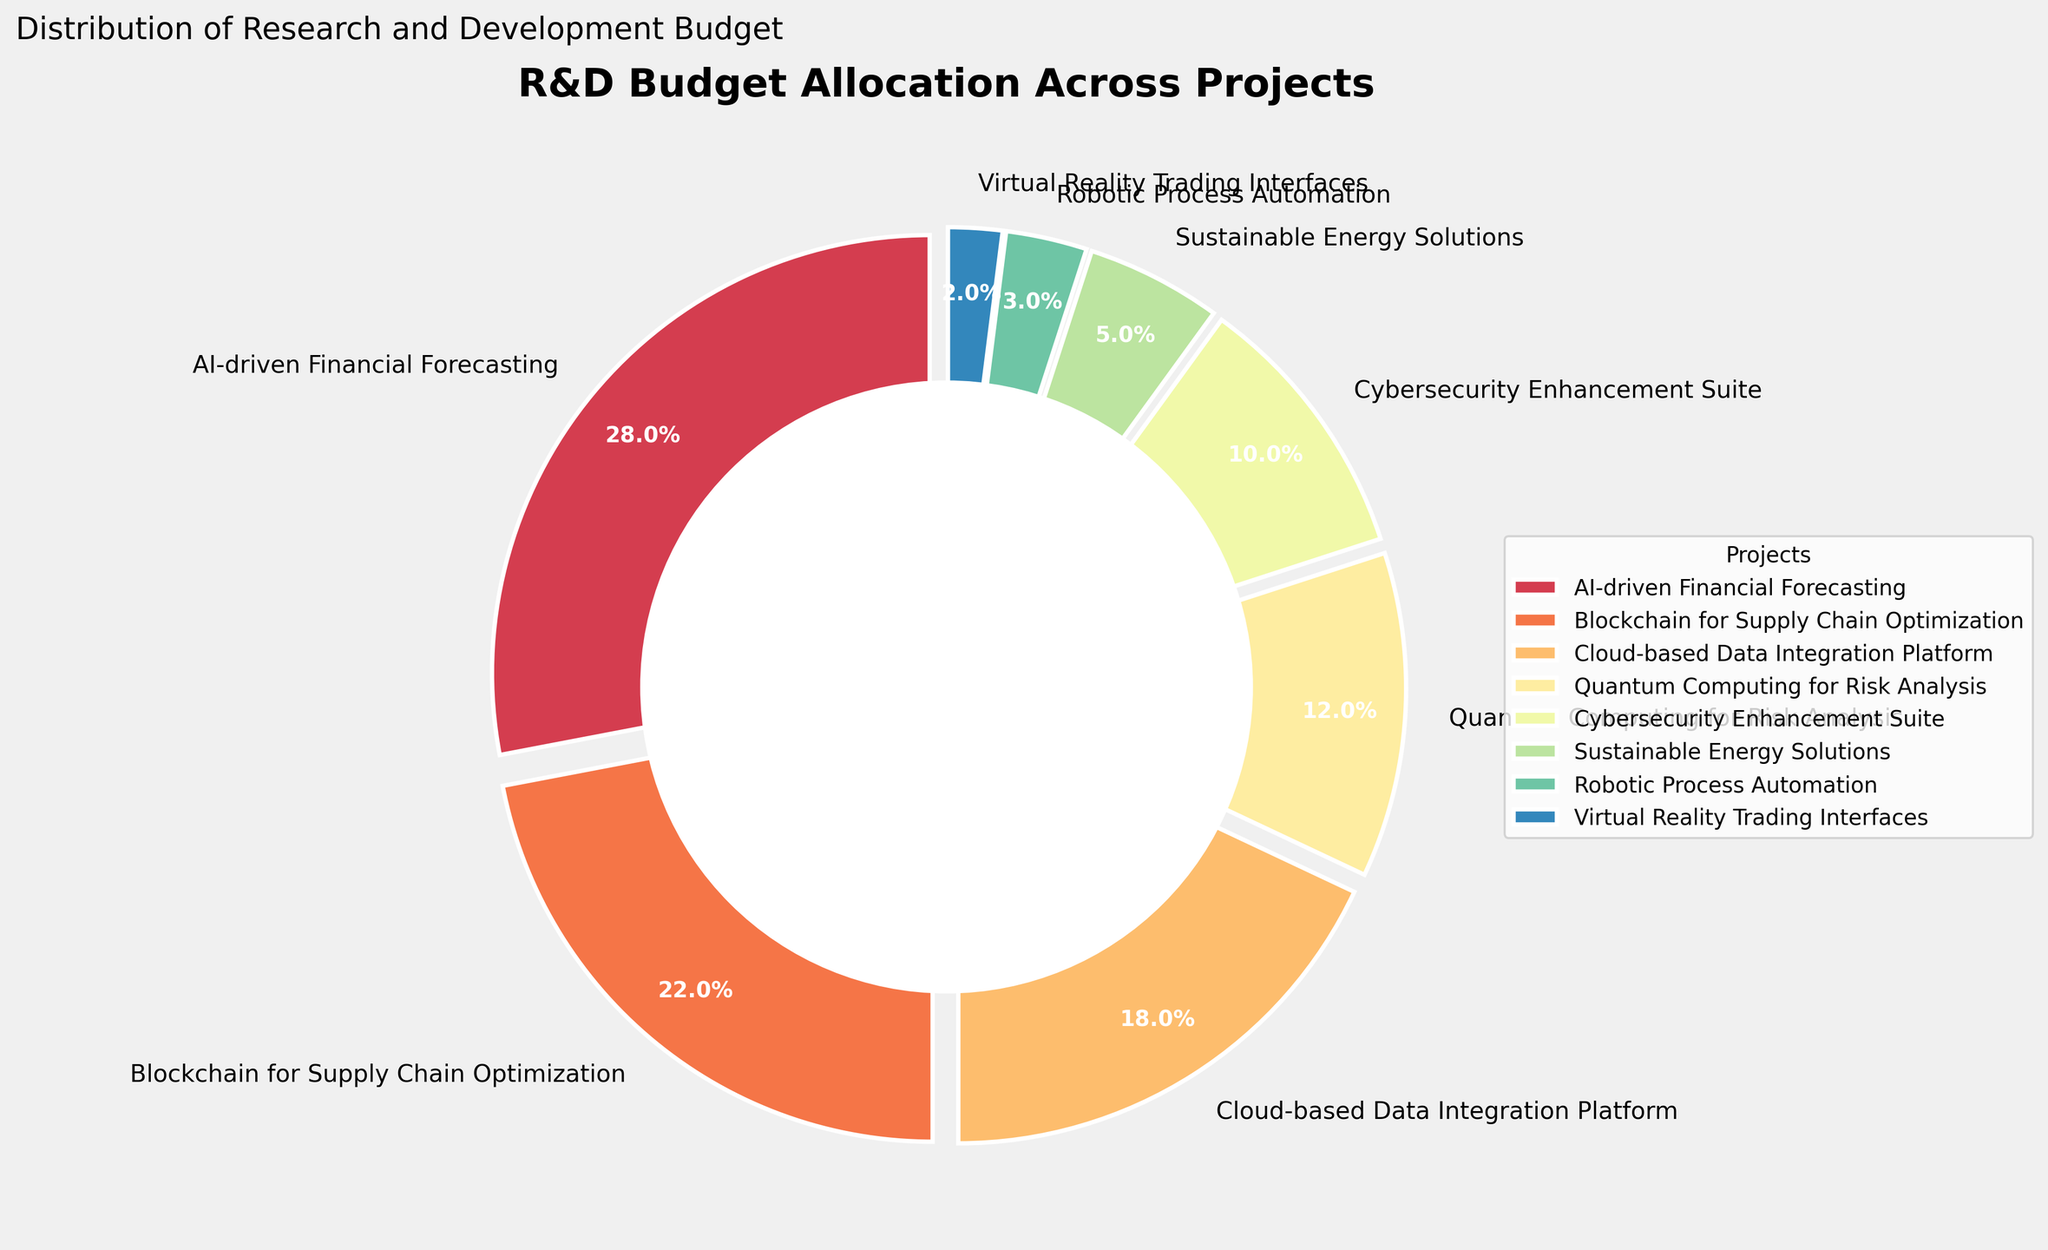What percentage of the budget is allocated to AI-driven Financial Forecasting? The figure shows that AI-driven Financial Forecasting has a budget allocation represented by a specific percentage segment of the pie. Looking directly at the figure, this segment is labeled with its percentage.
Answer: 28% Which project has the second-highest budget allocation? In the pie chart, the second-largest segment after AI-driven Financial Forecasting represents the second-highest budget allocation. This segment is labeled with its project name.
Answer: Blockchain for Supply Chain Optimization How much more budget percentage is allocated to Cloud-based Data Integration Platform compared to Sustainable Energy Solutions? First, find the budget percentages for both projects from the pie chart (18% for Cloud-based Data Integration Platform and 5% for Sustainable Energy Solutions). Then, subtract the smaller percentage from the larger one: 18% - 5% = 13%.
Answer: 13% Compare the budget allocations for Quantum Computing for Risk Analysis and Cybersecurity Enhancement Suite. Which has more, and by how much? Identify the budget percentages for both projects from the pie chart (12% for Quantum Computing for Risk Analysis and 10% for Cybersecurity Enhancement Suite). Subtract the smaller percentage from the larger one: 12% - 10% = 2%. Quantum Computing for Risk Analysis has 2% more.
Answer: Quantum Computing for Risk Analysis, 2% If projects with a budget allocation below 5% were combined into one category, what would be their total budget percentage? Identify the projects with budget allocations below 5% from the pie chart: Robotic Process Automation (3%) and Virtual Reality Trading Interfaces (2%). Sum these percentages: 3% + 2% = 5%.
Answer: 5% What is the overall budget percentage for the three highest-funded projects? Identify the three highest-funded projects from the pie chart, which are AI-driven Financial Forecasting (28%), Blockchain for Supply Chain Optimization (22%), and Cloud-based Data Integration Platform (18%). Sum these percentages: 28% + 22% + 18% = 68%.
Answer: 68% Which project has the smallest budget allocation, and what is its percentage? The smallest segment in the pie chart represents the project with the smallest budget allocation. This segment is labeled as Virtual Reality Trading Interfaces with its percentage.
Answer: Virtual Reality Trading Interfaces, 2% How do the budget allocations for Cybersecurity Enhancement Suite and Quantum Computing for Risk Analysis compare visually in terms of segment size? The pie chart segments for Cybersecurity Enhancement Suite (10%) and Quantum Computing for Risk Analysis (12%) are adjacent and can be visually compared. The segment for Quantum Computing for Risk Analysis is slightly larger than that for Cybersecurity Enhancement Suite.
Answer: Quantum Computing for Risk Analysis is larger 